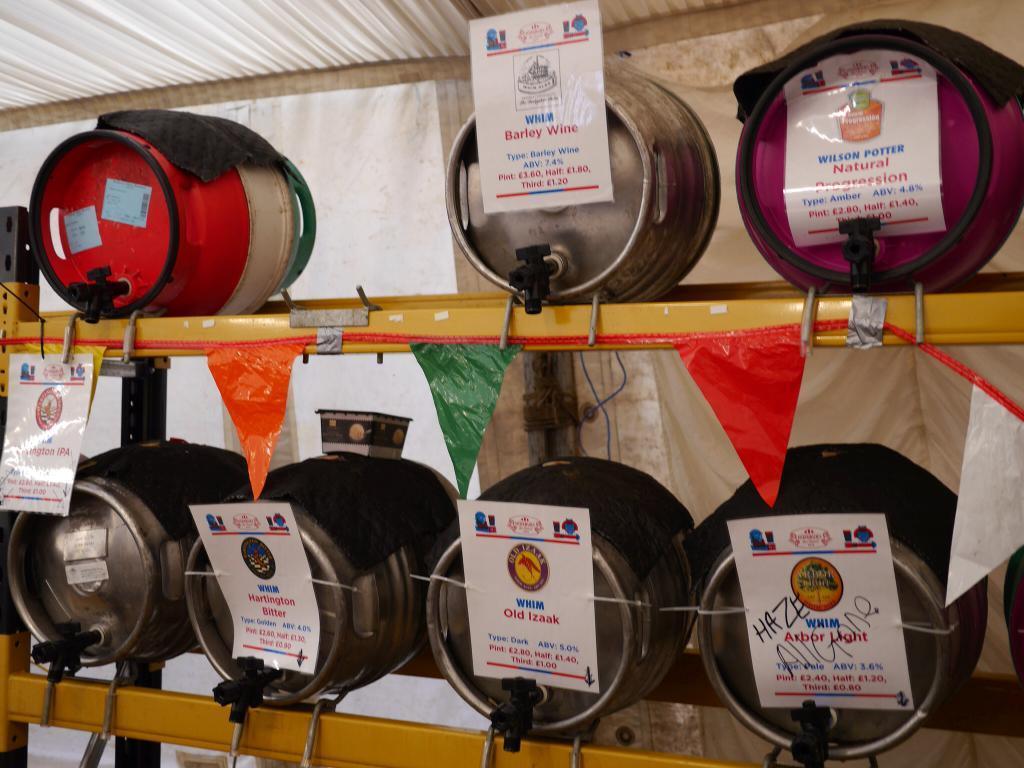Could you give a brief overview of what you see in this image? In the background it looks like a tent. In this picture we can see the objects arranged in a sequence manner in the racks. We can see the colorful paper flags and a rope. We can see the paper notes with some information and logos. 